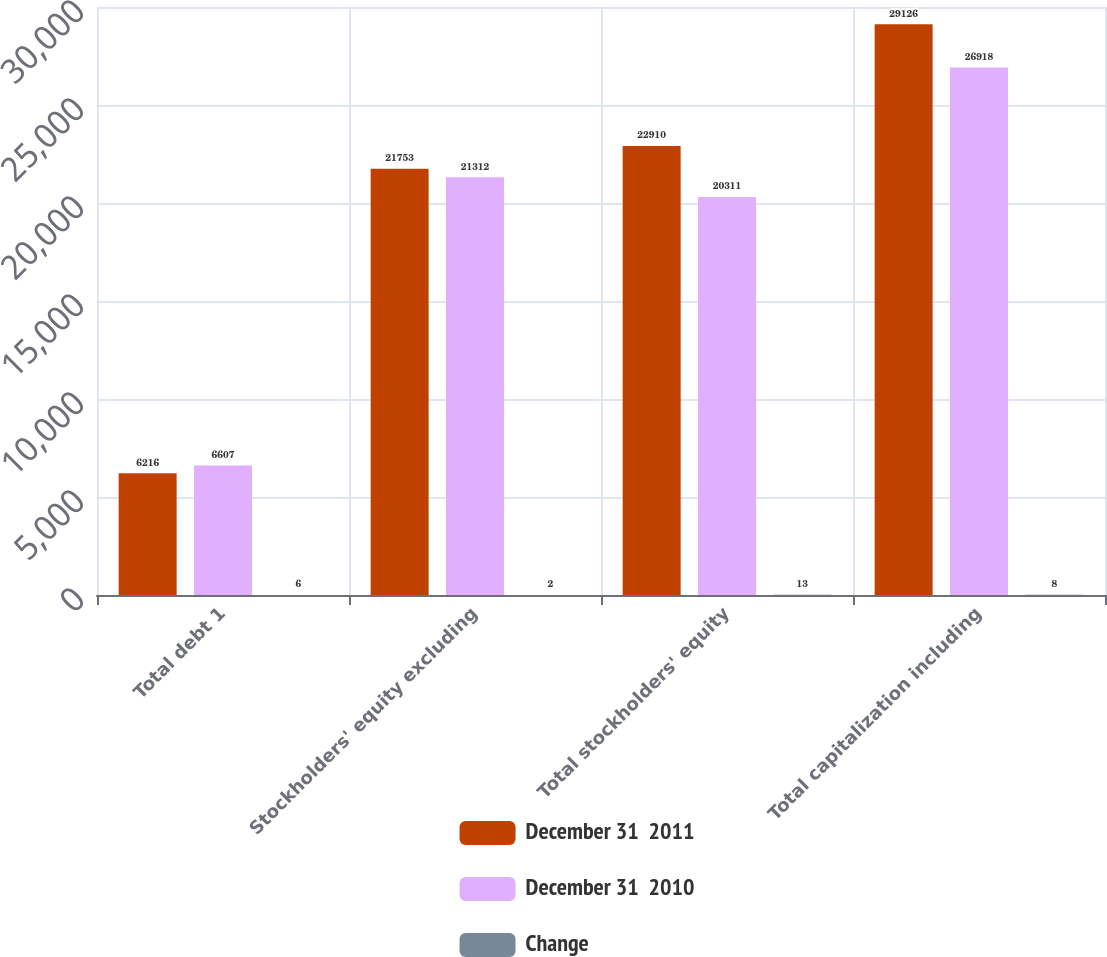Convert chart to OTSL. <chart><loc_0><loc_0><loc_500><loc_500><stacked_bar_chart><ecel><fcel>Total debt 1<fcel>Stockholders' equity excluding<fcel>Total stockholders' equity<fcel>Total capitalization including<nl><fcel>December 31  2011<fcel>6216<fcel>21753<fcel>22910<fcel>29126<nl><fcel>December 31  2010<fcel>6607<fcel>21312<fcel>20311<fcel>26918<nl><fcel>Change<fcel>6<fcel>2<fcel>13<fcel>8<nl></chart> 